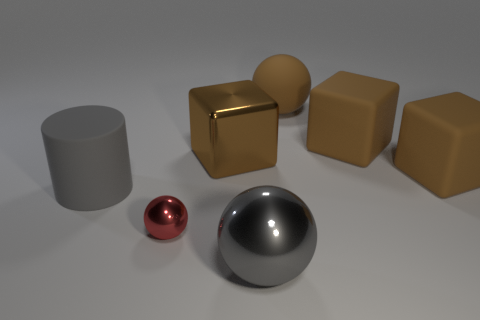There is a small shiny sphere; how many metallic spheres are to the right of it?
Offer a very short reply. 1. Do the large matte ball and the big metal cube have the same color?
Make the answer very short. Yes. What number of large cubes have the same color as the matte ball?
Give a very brief answer. 3. Is the number of brown cubes greater than the number of things?
Offer a very short reply. No. There is a matte object that is in front of the brown metallic thing and on the right side of the big shiny sphere; how big is it?
Offer a terse response. Large. Do the big gray object behind the gray shiny thing and the big sphere that is behind the large metal ball have the same material?
Offer a terse response. Yes. What is the shape of the gray metallic object that is the same size as the shiny cube?
Offer a very short reply. Sphere. Are there fewer gray cylinders than small green matte cylinders?
Keep it short and to the point. No. Are there any metallic spheres that are to the left of the brown block that is to the left of the gray metal sphere?
Offer a very short reply. Yes. Is there a large gray metal thing in front of the ball that is to the left of the large cube to the left of the brown sphere?
Keep it short and to the point. Yes. 